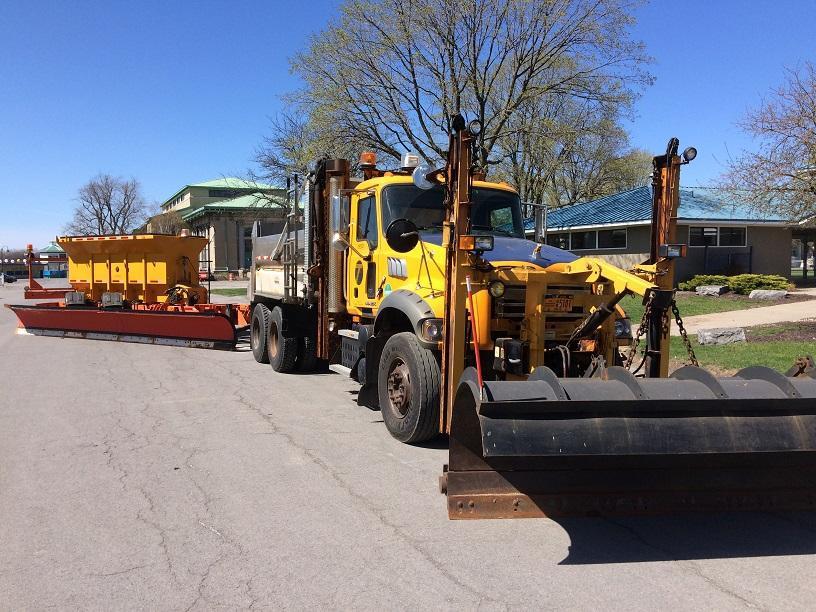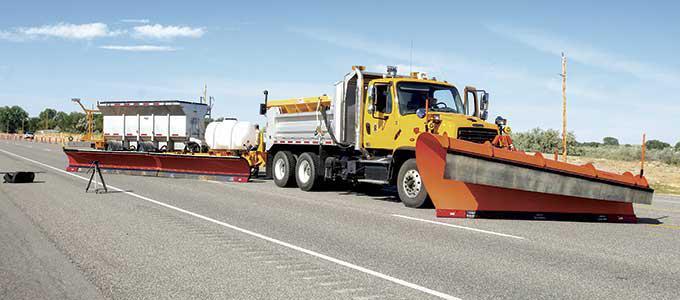The first image is the image on the left, the second image is the image on the right. Examine the images to the left and right. Is the description "A yellow truck is facing left." accurate? Answer yes or no. No. 